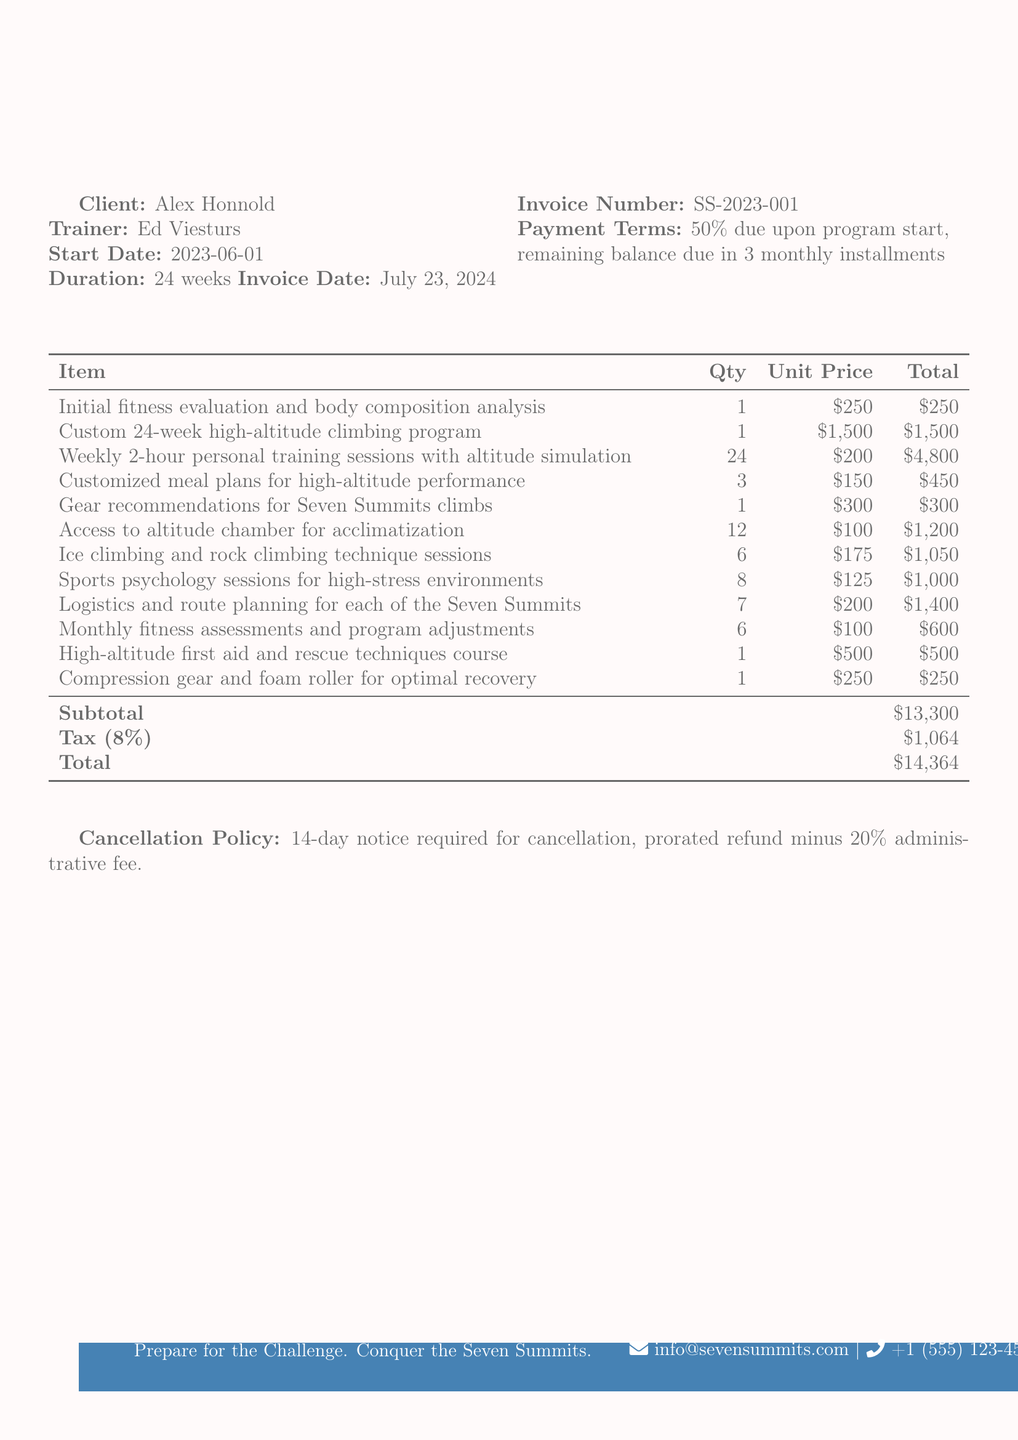what is the client name? The client name is mentioned in the document under the header "Client".
Answer: Alex Honnold who is the trainer? The trainer's name is listed in the document alongside the client name.
Answer: Ed Viesturs when does the program start? The start date of the program is specified in the document.
Answer: 2023-06-01 what is the total amount due? The total amount is calculated at the end of the document and provided there.
Answer: $14,364 how many weeks is the training program? The duration of the program is noted in the document, indicating how long it will last.
Answer: 24 weeks what is the tax rate applied? The document states the tax rate applicable to the subtotal.
Answer: 8% how many one-on-one training sessions are included? The total quantity of one-on-one training sessions is detailed in the item's list.
Answer: 24 what is the cancellation policy? The document outlines the cancellation policy, which is mentioned at the end.
Answer: 14-day notice required for cancellation, prorated refund minus 20% administrative fee what is the subtotal amount listed? The subtotal amount is shown in the tabular summary section of the document.
Answer: $13,300 